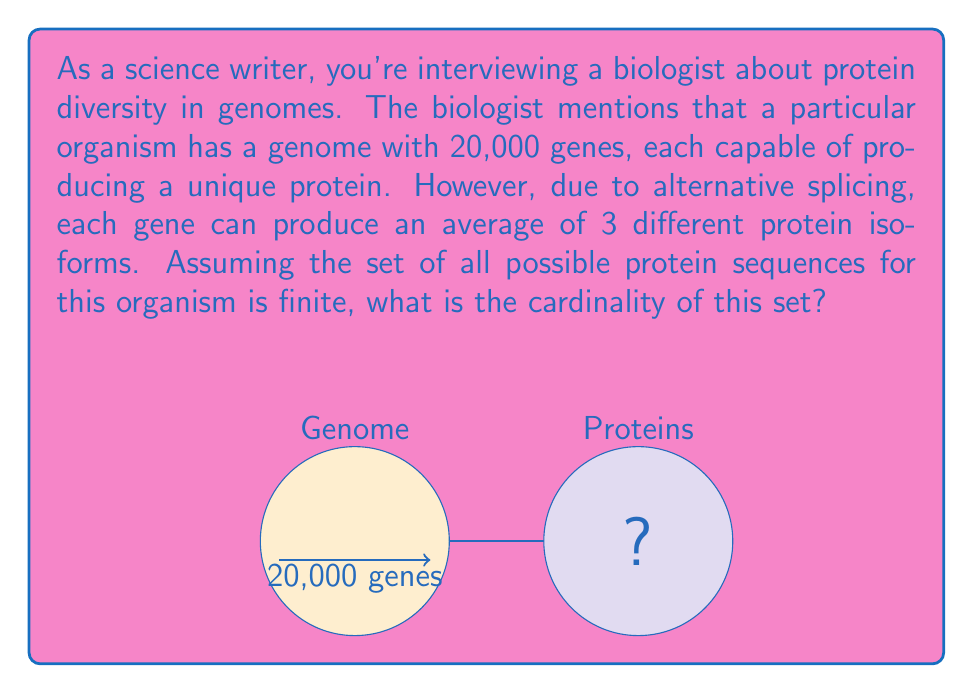Give your solution to this math problem. Let's approach this step-by-step:

1) First, we need to understand what the question is asking. We're looking for the cardinality of the set of all possible protein sequences, which means we need to count the total number of unique proteins that can be produced.

2) We're given two key pieces of information:
   - The organism has 20,000 genes
   - Each gene can produce an average of 3 different protein isoforms due to alternative splicing

3) To find the total number of unique proteins, we need to multiply the number of genes by the average number of protein isoforms per gene:

   $$ \text{Total proteins} = \text{Number of genes} \times \text{Average protein isoforms per gene} $$

4) Plugging in the numbers:

   $$ \text{Total proteins} = 20,000 \times 3 = 60,000 $$

5) In set theory, the cardinality of a finite set is simply the number of elements in that set. Therefore, the cardinality of the set of all possible protein sequences for this organism is 60,000.

6) We can express this formally as:

   $$ |\text{Protein Sequences}| = 60,000 $$

   Where $|\cdot|$ denotes the cardinality of a set.
Answer: 60,000 